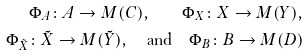<formula> <loc_0><loc_0><loc_500><loc_500>\Phi _ { A } \colon A \to M ( C ) , \quad \Phi _ { X } \colon X \to M ( Y ) , \\ \Phi _ { \tilde { X } } \colon \tilde { X } \to M ( \tilde { Y } ) , \quad \text {and} \quad \Phi _ { B } \colon B \to M ( D )</formula> 